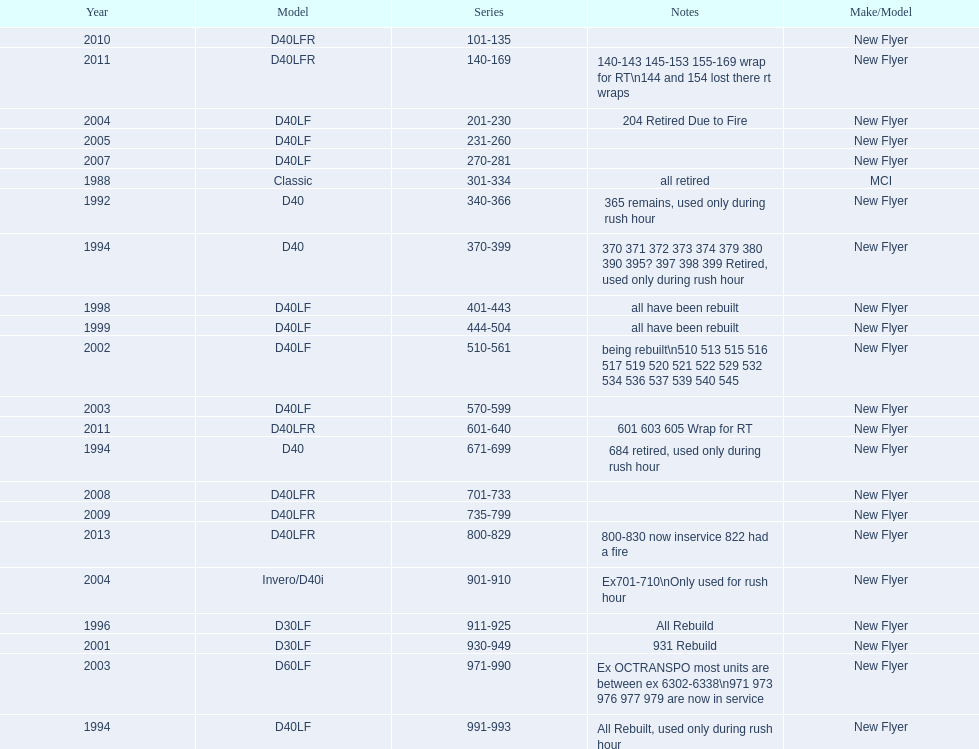Which buses are the newest in the current fleet? 800-829. 